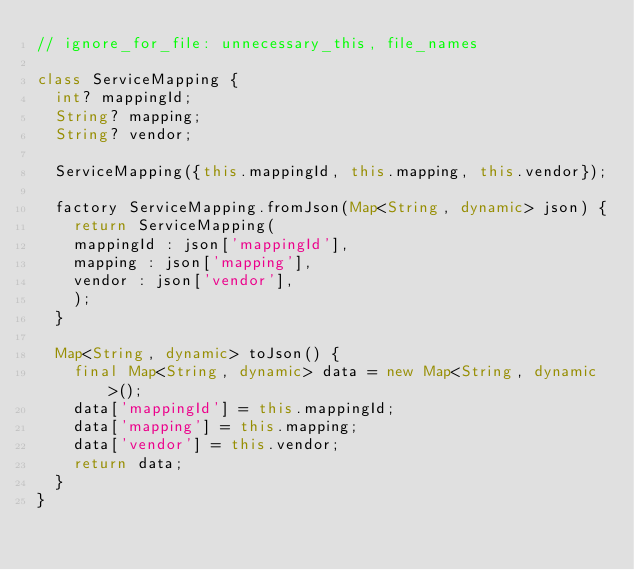Convert code to text. <code><loc_0><loc_0><loc_500><loc_500><_Dart_>// ignore_for_file: unnecessary_this, file_names

class ServiceMapping {
  int? mappingId;
  String? mapping;
  String? vendor;

  ServiceMapping({this.mappingId, this.mapping, this.vendor});

  factory ServiceMapping.fromJson(Map<String, dynamic> json) {
    return ServiceMapping(
    mappingId : json['mappingId'],
    mapping : json['mapping'],
    vendor : json['vendor'],
    );
  }

  Map<String, dynamic> toJson() {
    final Map<String, dynamic> data = new Map<String, dynamic>();
    data['mappingId'] = this.mappingId;
    data['mapping'] = this.mapping;
    data['vendor'] = this.vendor;
    return data;
  }
}
</code> 